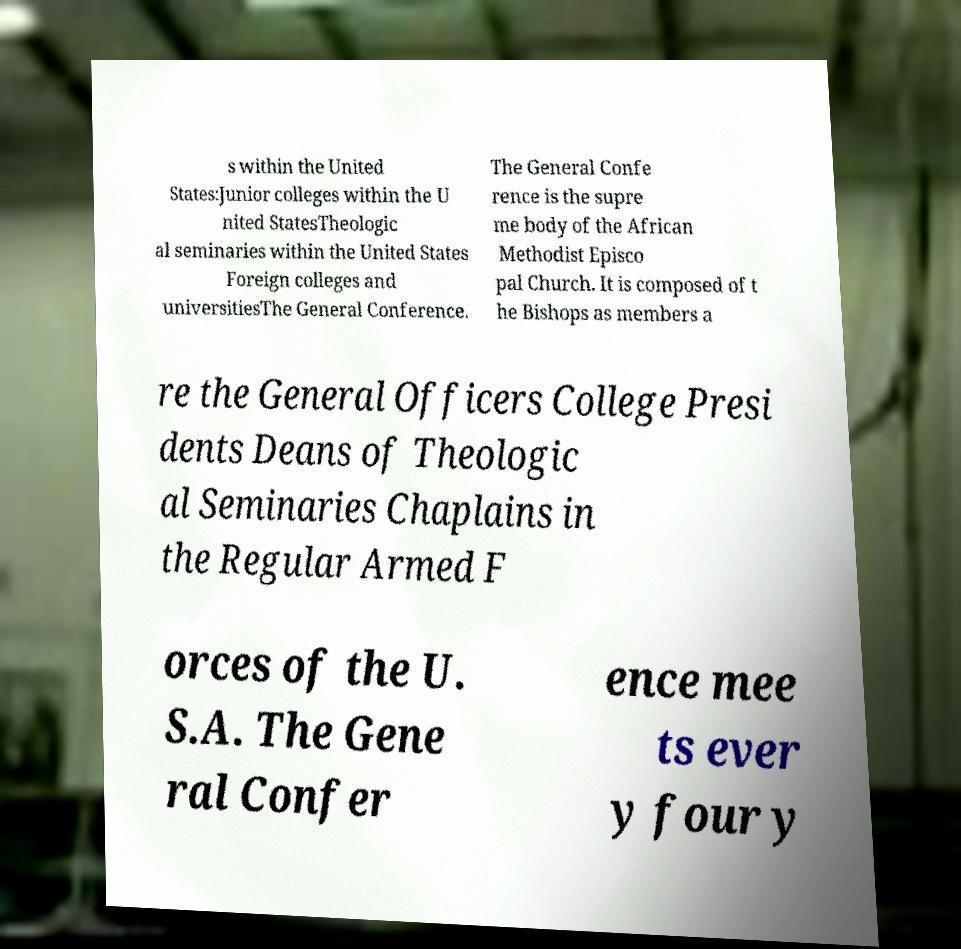Please read and relay the text visible in this image. What does it say? s within the United States:Junior colleges within the U nited StatesTheologic al seminaries within the United States Foreign colleges and universitiesThe General Conference. The General Confe rence is the supre me body of the African Methodist Episco pal Church. It is composed of t he Bishops as members a re the General Officers College Presi dents Deans of Theologic al Seminaries Chaplains in the Regular Armed F orces of the U. S.A. The Gene ral Confer ence mee ts ever y four y 